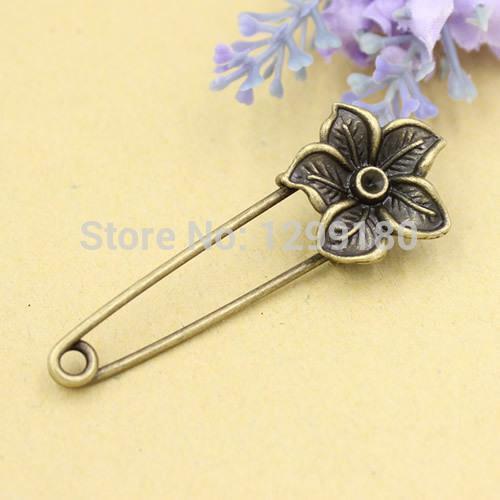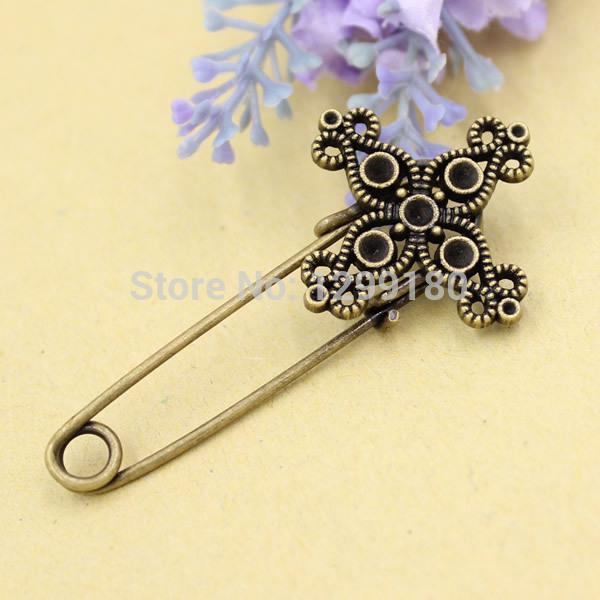The first image is the image on the left, the second image is the image on the right. For the images displayed, is the sentence "There is an animal on one of the clips." factually correct? Answer yes or no. No. 